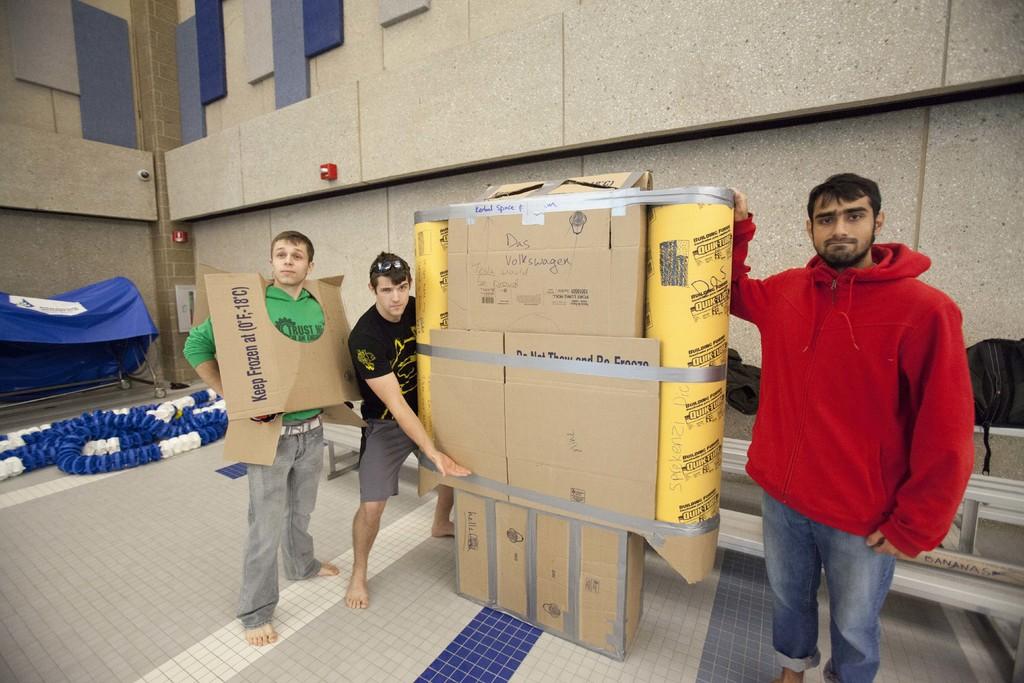What does the box the guy on the right is wearing say?
Offer a terse response. Keep frozen at 0f, 18c. 